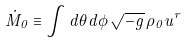Convert formula to latex. <formula><loc_0><loc_0><loc_500><loc_500>\dot { M } _ { 0 } \equiv \int d \theta d \phi \, \sqrt { - g } \, \rho _ { 0 } u ^ { r }</formula> 